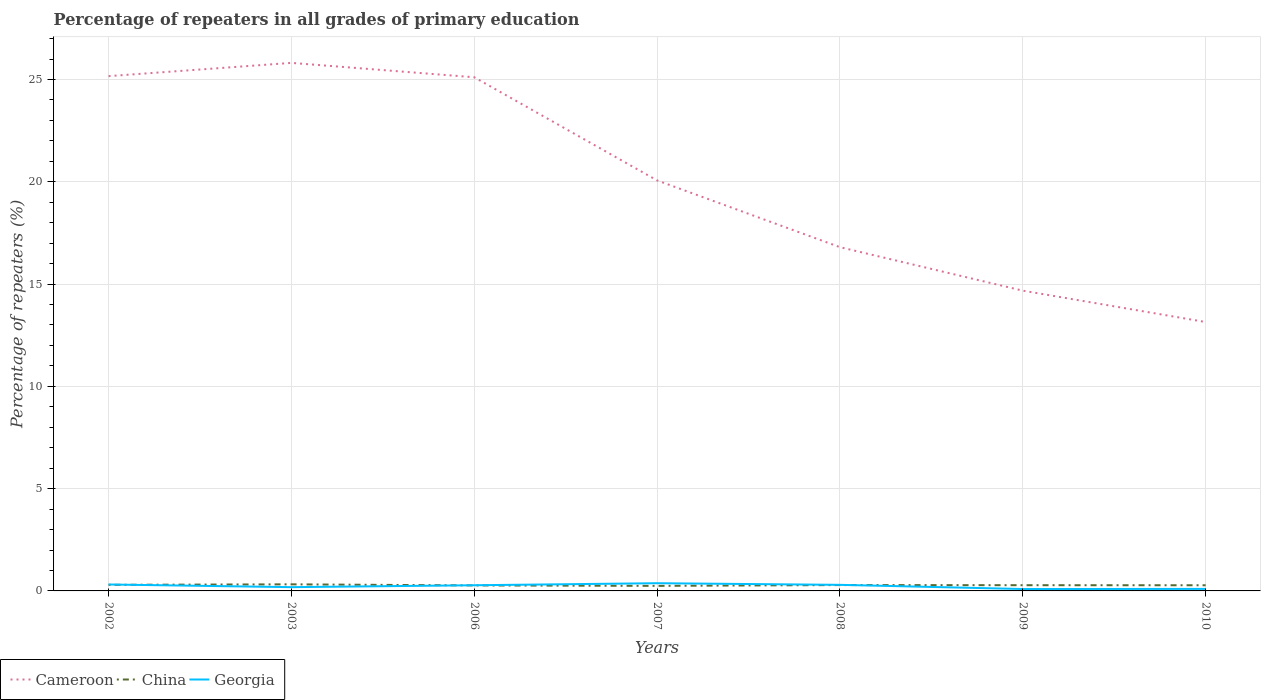How many different coloured lines are there?
Provide a succinct answer. 3. Does the line corresponding to Cameroon intersect with the line corresponding to Georgia?
Keep it short and to the point. No. Across all years, what is the maximum percentage of repeaters in Cameroon?
Give a very brief answer. 13.14. In which year was the percentage of repeaters in China maximum?
Your answer should be very brief. 2007. What is the total percentage of repeaters in Georgia in the graph?
Make the answer very short. 0.22. What is the difference between the highest and the second highest percentage of repeaters in Georgia?
Your answer should be very brief. 0.28. Is the percentage of repeaters in Georgia strictly greater than the percentage of repeaters in China over the years?
Give a very brief answer. No. What is the difference between two consecutive major ticks on the Y-axis?
Give a very brief answer. 5. Are the values on the major ticks of Y-axis written in scientific E-notation?
Provide a succinct answer. No. Where does the legend appear in the graph?
Offer a very short reply. Bottom left. How are the legend labels stacked?
Your answer should be very brief. Horizontal. What is the title of the graph?
Offer a very short reply. Percentage of repeaters in all grades of primary education. Does "Qatar" appear as one of the legend labels in the graph?
Give a very brief answer. No. What is the label or title of the X-axis?
Your response must be concise. Years. What is the label or title of the Y-axis?
Provide a short and direct response. Percentage of repeaters (%). What is the Percentage of repeaters (%) of Cameroon in 2002?
Offer a very short reply. 25.17. What is the Percentage of repeaters (%) of China in 2002?
Offer a very short reply. 0.3. What is the Percentage of repeaters (%) in Georgia in 2002?
Make the answer very short. 0.31. What is the Percentage of repeaters (%) of Cameroon in 2003?
Ensure brevity in your answer.  25.81. What is the Percentage of repeaters (%) of China in 2003?
Your response must be concise. 0.32. What is the Percentage of repeaters (%) of Georgia in 2003?
Ensure brevity in your answer.  0.18. What is the Percentage of repeaters (%) of Cameroon in 2006?
Offer a very short reply. 25.11. What is the Percentage of repeaters (%) of China in 2006?
Keep it short and to the point. 0.27. What is the Percentage of repeaters (%) of Georgia in 2006?
Offer a terse response. 0.28. What is the Percentage of repeaters (%) of Cameroon in 2007?
Give a very brief answer. 20.07. What is the Percentage of repeaters (%) of China in 2007?
Your answer should be compact. 0.25. What is the Percentage of repeaters (%) in Georgia in 2007?
Your response must be concise. 0.38. What is the Percentage of repeaters (%) of Cameroon in 2008?
Provide a succinct answer. 16.8. What is the Percentage of repeaters (%) of China in 2008?
Your response must be concise. 0.29. What is the Percentage of repeaters (%) of Georgia in 2008?
Offer a very short reply. 0.3. What is the Percentage of repeaters (%) of Cameroon in 2009?
Your response must be concise. 14.68. What is the Percentage of repeaters (%) of China in 2009?
Your answer should be very brief. 0.28. What is the Percentage of repeaters (%) in Georgia in 2009?
Make the answer very short. 0.09. What is the Percentage of repeaters (%) in Cameroon in 2010?
Provide a succinct answer. 13.14. What is the Percentage of repeaters (%) of China in 2010?
Your answer should be compact. 0.28. What is the Percentage of repeaters (%) in Georgia in 2010?
Provide a succinct answer. 0.1. Across all years, what is the maximum Percentage of repeaters (%) of Cameroon?
Keep it short and to the point. 25.81. Across all years, what is the maximum Percentage of repeaters (%) in China?
Provide a short and direct response. 0.32. Across all years, what is the maximum Percentage of repeaters (%) of Georgia?
Give a very brief answer. 0.38. Across all years, what is the minimum Percentage of repeaters (%) of Cameroon?
Your answer should be very brief. 13.14. Across all years, what is the minimum Percentage of repeaters (%) of China?
Provide a succinct answer. 0.25. Across all years, what is the minimum Percentage of repeaters (%) in Georgia?
Keep it short and to the point. 0.09. What is the total Percentage of repeaters (%) in Cameroon in the graph?
Ensure brevity in your answer.  140.78. What is the total Percentage of repeaters (%) of China in the graph?
Offer a terse response. 1.98. What is the total Percentage of repeaters (%) in Georgia in the graph?
Provide a succinct answer. 1.64. What is the difference between the Percentage of repeaters (%) of Cameroon in 2002 and that in 2003?
Keep it short and to the point. -0.65. What is the difference between the Percentage of repeaters (%) of China in 2002 and that in 2003?
Offer a very short reply. -0.02. What is the difference between the Percentage of repeaters (%) of Georgia in 2002 and that in 2003?
Offer a very short reply. 0.13. What is the difference between the Percentage of repeaters (%) in Cameroon in 2002 and that in 2006?
Give a very brief answer. 0.06. What is the difference between the Percentage of repeaters (%) in China in 2002 and that in 2006?
Give a very brief answer. 0.03. What is the difference between the Percentage of repeaters (%) in Georgia in 2002 and that in 2006?
Provide a short and direct response. 0.04. What is the difference between the Percentage of repeaters (%) in Cameroon in 2002 and that in 2007?
Provide a short and direct response. 5.1. What is the difference between the Percentage of repeaters (%) of China in 2002 and that in 2007?
Make the answer very short. 0.05. What is the difference between the Percentage of repeaters (%) of Georgia in 2002 and that in 2007?
Your response must be concise. -0.06. What is the difference between the Percentage of repeaters (%) in Cameroon in 2002 and that in 2008?
Your answer should be very brief. 8.36. What is the difference between the Percentage of repeaters (%) of China in 2002 and that in 2008?
Keep it short and to the point. 0.01. What is the difference between the Percentage of repeaters (%) in Georgia in 2002 and that in 2008?
Make the answer very short. 0.02. What is the difference between the Percentage of repeaters (%) in Cameroon in 2002 and that in 2009?
Offer a very short reply. 10.49. What is the difference between the Percentage of repeaters (%) of China in 2002 and that in 2009?
Ensure brevity in your answer.  0.02. What is the difference between the Percentage of repeaters (%) of Georgia in 2002 and that in 2009?
Your answer should be compact. 0.22. What is the difference between the Percentage of repeaters (%) of Cameroon in 2002 and that in 2010?
Your response must be concise. 12.02. What is the difference between the Percentage of repeaters (%) in China in 2002 and that in 2010?
Give a very brief answer. 0.02. What is the difference between the Percentage of repeaters (%) in Georgia in 2002 and that in 2010?
Make the answer very short. 0.22. What is the difference between the Percentage of repeaters (%) in Cameroon in 2003 and that in 2006?
Provide a succinct answer. 0.7. What is the difference between the Percentage of repeaters (%) of China in 2003 and that in 2006?
Keep it short and to the point. 0.05. What is the difference between the Percentage of repeaters (%) of Georgia in 2003 and that in 2006?
Keep it short and to the point. -0.09. What is the difference between the Percentage of repeaters (%) in Cameroon in 2003 and that in 2007?
Provide a short and direct response. 5.75. What is the difference between the Percentage of repeaters (%) of China in 2003 and that in 2007?
Ensure brevity in your answer.  0.08. What is the difference between the Percentage of repeaters (%) of Georgia in 2003 and that in 2007?
Give a very brief answer. -0.19. What is the difference between the Percentage of repeaters (%) of Cameroon in 2003 and that in 2008?
Your answer should be very brief. 9.01. What is the difference between the Percentage of repeaters (%) in China in 2003 and that in 2008?
Your response must be concise. 0.04. What is the difference between the Percentage of repeaters (%) of Georgia in 2003 and that in 2008?
Keep it short and to the point. -0.11. What is the difference between the Percentage of repeaters (%) in Cameroon in 2003 and that in 2009?
Make the answer very short. 11.13. What is the difference between the Percentage of repeaters (%) of China in 2003 and that in 2009?
Ensure brevity in your answer.  0.04. What is the difference between the Percentage of repeaters (%) of Georgia in 2003 and that in 2009?
Provide a short and direct response. 0.09. What is the difference between the Percentage of repeaters (%) in Cameroon in 2003 and that in 2010?
Your answer should be very brief. 12.67. What is the difference between the Percentage of repeaters (%) in China in 2003 and that in 2010?
Offer a very short reply. 0.05. What is the difference between the Percentage of repeaters (%) of Georgia in 2003 and that in 2010?
Ensure brevity in your answer.  0.09. What is the difference between the Percentage of repeaters (%) in Cameroon in 2006 and that in 2007?
Your answer should be very brief. 5.04. What is the difference between the Percentage of repeaters (%) of China in 2006 and that in 2007?
Keep it short and to the point. 0.02. What is the difference between the Percentage of repeaters (%) of Georgia in 2006 and that in 2007?
Keep it short and to the point. -0.1. What is the difference between the Percentage of repeaters (%) of Cameroon in 2006 and that in 2008?
Provide a succinct answer. 8.31. What is the difference between the Percentage of repeaters (%) in China in 2006 and that in 2008?
Provide a short and direct response. -0.02. What is the difference between the Percentage of repeaters (%) of Georgia in 2006 and that in 2008?
Your response must be concise. -0.02. What is the difference between the Percentage of repeaters (%) of Cameroon in 2006 and that in 2009?
Ensure brevity in your answer.  10.43. What is the difference between the Percentage of repeaters (%) of China in 2006 and that in 2009?
Your answer should be compact. -0.01. What is the difference between the Percentage of repeaters (%) of Georgia in 2006 and that in 2009?
Your answer should be compact. 0.18. What is the difference between the Percentage of repeaters (%) of Cameroon in 2006 and that in 2010?
Ensure brevity in your answer.  11.97. What is the difference between the Percentage of repeaters (%) in China in 2006 and that in 2010?
Keep it short and to the point. -0.01. What is the difference between the Percentage of repeaters (%) in Georgia in 2006 and that in 2010?
Your answer should be compact. 0.18. What is the difference between the Percentage of repeaters (%) of Cameroon in 2007 and that in 2008?
Keep it short and to the point. 3.26. What is the difference between the Percentage of repeaters (%) of China in 2007 and that in 2008?
Offer a very short reply. -0.04. What is the difference between the Percentage of repeaters (%) in Georgia in 2007 and that in 2008?
Make the answer very short. 0.08. What is the difference between the Percentage of repeaters (%) in Cameroon in 2007 and that in 2009?
Offer a terse response. 5.39. What is the difference between the Percentage of repeaters (%) of China in 2007 and that in 2009?
Provide a succinct answer. -0.03. What is the difference between the Percentage of repeaters (%) in Georgia in 2007 and that in 2009?
Give a very brief answer. 0.28. What is the difference between the Percentage of repeaters (%) in Cameroon in 2007 and that in 2010?
Give a very brief answer. 6.92. What is the difference between the Percentage of repeaters (%) in China in 2007 and that in 2010?
Make the answer very short. -0.03. What is the difference between the Percentage of repeaters (%) of Georgia in 2007 and that in 2010?
Your answer should be compact. 0.28. What is the difference between the Percentage of repeaters (%) in Cameroon in 2008 and that in 2009?
Offer a terse response. 2.13. What is the difference between the Percentage of repeaters (%) in China in 2008 and that in 2009?
Your answer should be very brief. 0.01. What is the difference between the Percentage of repeaters (%) of Georgia in 2008 and that in 2009?
Keep it short and to the point. 0.2. What is the difference between the Percentage of repeaters (%) of Cameroon in 2008 and that in 2010?
Provide a succinct answer. 3.66. What is the difference between the Percentage of repeaters (%) of China in 2008 and that in 2010?
Ensure brevity in your answer.  0.01. What is the difference between the Percentage of repeaters (%) in Georgia in 2008 and that in 2010?
Offer a very short reply. 0.2. What is the difference between the Percentage of repeaters (%) of Cameroon in 2009 and that in 2010?
Offer a very short reply. 1.53. What is the difference between the Percentage of repeaters (%) in China in 2009 and that in 2010?
Provide a succinct answer. 0. What is the difference between the Percentage of repeaters (%) of Georgia in 2009 and that in 2010?
Keep it short and to the point. -0.01. What is the difference between the Percentage of repeaters (%) in Cameroon in 2002 and the Percentage of repeaters (%) in China in 2003?
Give a very brief answer. 24.84. What is the difference between the Percentage of repeaters (%) in Cameroon in 2002 and the Percentage of repeaters (%) in Georgia in 2003?
Provide a short and direct response. 24.98. What is the difference between the Percentage of repeaters (%) of China in 2002 and the Percentage of repeaters (%) of Georgia in 2003?
Make the answer very short. 0.11. What is the difference between the Percentage of repeaters (%) in Cameroon in 2002 and the Percentage of repeaters (%) in China in 2006?
Offer a very short reply. 24.9. What is the difference between the Percentage of repeaters (%) in Cameroon in 2002 and the Percentage of repeaters (%) in Georgia in 2006?
Offer a very short reply. 24.89. What is the difference between the Percentage of repeaters (%) of China in 2002 and the Percentage of repeaters (%) of Georgia in 2006?
Offer a terse response. 0.02. What is the difference between the Percentage of repeaters (%) of Cameroon in 2002 and the Percentage of repeaters (%) of China in 2007?
Provide a short and direct response. 24.92. What is the difference between the Percentage of repeaters (%) of Cameroon in 2002 and the Percentage of repeaters (%) of Georgia in 2007?
Your response must be concise. 24.79. What is the difference between the Percentage of repeaters (%) of China in 2002 and the Percentage of repeaters (%) of Georgia in 2007?
Ensure brevity in your answer.  -0.08. What is the difference between the Percentage of repeaters (%) in Cameroon in 2002 and the Percentage of repeaters (%) in China in 2008?
Your answer should be compact. 24.88. What is the difference between the Percentage of repeaters (%) in Cameroon in 2002 and the Percentage of repeaters (%) in Georgia in 2008?
Make the answer very short. 24.87. What is the difference between the Percentage of repeaters (%) in Cameroon in 2002 and the Percentage of repeaters (%) in China in 2009?
Your response must be concise. 24.89. What is the difference between the Percentage of repeaters (%) of Cameroon in 2002 and the Percentage of repeaters (%) of Georgia in 2009?
Your answer should be very brief. 25.07. What is the difference between the Percentage of repeaters (%) in China in 2002 and the Percentage of repeaters (%) in Georgia in 2009?
Offer a terse response. 0.21. What is the difference between the Percentage of repeaters (%) in Cameroon in 2002 and the Percentage of repeaters (%) in China in 2010?
Offer a terse response. 24.89. What is the difference between the Percentage of repeaters (%) in Cameroon in 2002 and the Percentage of repeaters (%) in Georgia in 2010?
Make the answer very short. 25.07. What is the difference between the Percentage of repeaters (%) of China in 2002 and the Percentage of repeaters (%) of Georgia in 2010?
Keep it short and to the point. 0.2. What is the difference between the Percentage of repeaters (%) of Cameroon in 2003 and the Percentage of repeaters (%) of China in 2006?
Your response must be concise. 25.54. What is the difference between the Percentage of repeaters (%) of Cameroon in 2003 and the Percentage of repeaters (%) of Georgia in 2006?
Ensure brevity in your answer.  25.54. What is the difference between the Percentage of repeaters (%) in China in 2003 and the Percentage of repeaters (%) in Georgia in 2006?
Your response must be concise. 0.05. What is the difference between the Percentage of repeaters (%) in Cameroon in 2003 and the Percentage of repeaters (%) in China in 2007?
Provide a short and direct response. 25.57. What is the difference between the Percentage of repeaters (%) in Cameroon in 2003 and the Percentage of repeaters (%) in Georgia in 2007?
Provide a succinct answer. 25.44. What is the difference between the Percentage of repeaters (%) in China in 2003 and the Percentage of repeaters (%) in Georgia in 2007?
Provide a short and direct response. -0.06. What is the difference between the Percentage of repeaters (%) of Cameroon in 2003 and the Percentage of repeaters (%) of China in 2008?
Provide a short and direct response. 25.53. What is the difference between the Percentage of repeaters (%) in Cameroon in 2003 and the Percentage of repeaters (%) in Georgia in 2008?
Your answer should be very brief. 25.52. What is the difference between the Percentage of repeaters (%) of China in 2003 and the Percentage of repeaters (%) of Georgia in 2008?
Provide a short and direct response. 0.03. What is the difference between the Percentage of repeaters (%) of Cameroon in 2003 and the Percentage of repeaters (%) of China in 2009?
Ensure brevity in your answer.  25.53. What is the difference between the Percentage of repeaters (%) of Cameroon in 2003 and the Percentage of repeaters (%) of Georgia in 2009?
Give a very brief answer. 25.72. What is the difference between the Percentage of repeaters (%) of China in 2003 and the Percentage of repeaters (%) of Georgia in 2009?
Your response must be concise. 0.23. What is the difference between the Percentage of repeaters (%) of Cameroon in 2003 and the Percentage of repeaters (%) of China in 2010?
Your response must be concise. 25.54. What is the difference between the Percentage of repeaters (%) in Cameroon in 2003 and the Percentage of repeaters (%) in Georgia in 2010?
Keep it short and to the point. 25.71. What is the difference between the Percentage of repeaters (%) in China in 2003 and the Percentage of repeaters (%) in Georgia in 2010?
Provide a succinct answer. 0.22. What is the difference between the Percentage of repeaters (%) in Cameroon in 2006 and the Percentage of repeaters (%) in China in 2007?
Keep it short and to the point. 24.86. What is the difference between the Percentage of repeaters (%) in Cameroon in 2006 and the Percentage of repeaters (%) in Georgia in 2007?
Your response must be concise. 24.73. What is the difference between the Percentage of repeaters (%) of China in 2006 and the Percentage of repeaters (%) of Georgia in 2007?
Offer a terse response. -0.11. What is the difference between the Percentage of repeaters (%) of Cameroon in 2006 and the Percentage of repeaters (%) of China in 2008?
Ensure brevity in your answer.  24.82. What is the difference between the Percentage of repeaters (%) in Cameroon in 2006 and the Percentage of repeaters (%) in Georgia in 2008?
Ensure brevity in your answer.  24.81. What is the difference between the Percentage of repeaters (%) in China in 2006 and the Percentage of repeaters (%) in Georgia in 2008?
Make the answer very short. -0.03. What is the difference between the Percentage of repeaters (%) of Cameroon in 2006 and the Percentage of repeaters (%) of China in 2009?
Offer a very short reply. 24.83. What is the difference between the Percentage of repeaters (%) of Cameroon in 2006 and the Percentage of repeaters (%) of Georgia in 2009?
Your answer should be very brief. 25.02. What is the difference between the Percentage of repeaters (%) in China in 2006 and the Percentage of repeaters (%) in Georgia in 2009?
Your answer should be compact. 0.18. What is the difference between the Percentage of repeaters (%) in Cameroon in 2006 and the Percentage of repeaters (%) in China in 2010?
Give a very brief answer. 24.83. What is the difference between the Percentage of repeaters (%) in Cameroon in 2006 and the Percentage of repeaters (%) in Georgia in 2010?
Provide a short and direct response. 25.01. What is the difference between the Percentage of repeaters (%) of China in 2006 and the Percentage of repeaters (%) of Georgia in 2010?
Your answer should be very brief. 0.17. What is the difference between the Percentage of repeaters (%) of Cameroon in 2007 and the Percentage of repeaters (%) of China in 2008?
Give a very brief answer. 19.78. What is the difference between the Percentage of repeaters (%) in Cameroon in 2007 and the Percentage of repeaters (%) in Georgia in 2008?
Offer a very short reply. 19.77. What is the difference between the Percentage of repeaters (%) of China in 2007 and the Percentage of repeaters (%) of Georgia in 2008?
Provide a succinct answer. -0.05. What is the difference between the Percentage of repeaters (%) of Cameroon in 2007 and the Percentage of repeaters (%) of China in 2009?
Provide a short and direct response. 19.79. What is the difference between the Percentage of repeaters (%) of Cameroon in 2007 and the Percentage of repeaters (%) of Georgia in 2009?
Provide a short and direct response. 19.97. What is the difference between the Percentage of repeaters (%) of China in 2007 and the Percentage of repeaters (%) of Georgia in 2009?
Your answer should be compact. 0.15. What is the difference between the Percentage of repeaters (%) in Cameroon in 2007 and the Percentage of repeaters (%) in China in 2010?
Offer a terse response. 19.79. What is the difference between the Percentage of repeaters (%) in Cameroon in 2007 and the Percentage of repeaters (%) in Georgia in 2010?
Your answer should be very brief. 19.97. What is the difference between the Percentage of repeaters (%) of China in 2007 and the Percentage of repeaters (%) of Georgia in 2010?
Make the answer very short. 0.15. What is the difference between the Percentage of repeaters (%) of Cameroon in 2008 and the Percentage of repeaters (%) of China in 2009?
Provide a short and direct response. 16.52. What is the difference between the Percentage of repeaters (%) of Cameroon in 2008 and the Percentage of repeaters (%) of Georgia in 2009?
Your response must be concise. 16.71. What is the difference between the Percentage of repeaters (%) in China in 2008 and the Percentage of repeaters (%) in Georgia in 2009?
Your answer should be compact. 0.19. What is the difference between the Percentage of repeaters (%) in Cameroon in 2008 and the Percentage of repeaters (%) in China in 2010?
Keep it short and to the point. 16.53. What is the difference between the Percentage of repeaters (%) of Cameroon in 2008 and the Percentage of repeaters (%) of Georgia in 2010?
Provide a short and direct response. 16.71. What is the difference between the Percentage of repeaters (%) in China in 2008 and the Percentage of repeaters (%) in Georgia in 2010?
Offer a very short reply. 0.19. What is the difference between the Percentage of repeaters (%) in Cameroon in 2009 and the Percentage of repeaters (%) in China in 2010?
Your answer should be very brief. 14.4. What is the difference between the Percentage of repeaters (%) in Cameroon in 2009 and the Percentage of repeaters (%) in Georgia in 2010?
Your answer should be very brief. 14.58. What is the difference between the Percentage of repeaters (%) in China in 2009 and the Percentage of repeaters (%) in Georgia in 2010?
Make the answer very short. 0.18. What is the average Percentage of repeaters (%) in Cameroon per year?
Your response must be concise. 20.11. What is the average Percentage of repeaters (%) in China per year?
Make the answer very short. 0.28. What is the average Percentage of repeaters (%) of Georgia per year?
Offer a very short reply. 0.23. In the year 2002, what is the difference between the Percentage of repeaters (%) of Cameroon and Percentage of repeaters (%) of China?
Provide a succinct answer. 24.87. In the year 2002, what is the difference between the Percentage of repeaters (%) in Cameroon and Percentage of repeaters (%) in Georgia?
Your response must be concise. 24.85. In the year 2002, what is the difference between the Percentage of repeaters (%) of China and Percentage of repeaters (%) of Georgia?
Offer a very short reply. -0.02. In the year 2003, what is the difference between the Percentage of repeaters (%) of Cameroon and Percentage of repeaters (%) of China?
Your answer should be very brief. 25.49. In the year 2003, what is the difference between the Percentage of repeaters (%) in Cameroon and Percentage of repeaters (%) in Georgia?
Offer a terse response. 25.63. In the year 2003, what is the difference between the Percentage of repeaters (%) in China and Percentage of repeaters (%) in Georgia?
Provide a succinct answer. 0.14. In the year 2006, what is the difference between the Percentage of repeaters (%) of Cameroon and Percentage of repeaters (%) of China?
Ensure brevity in your answer.  24.84. In the year 2006, what is the difference between the Percentage of repeaters (%) in Cameroon and Percentage of repeaters (%) in Georgia?
Provide a short and direct response. 24.83. In the year 2006, what is the difference between the Percentage of repeaters (%) of China and Percentage of repeaters (%) of Georgia?
Offer a terse response. -0.01. In the year 2007, what is the difference between the Percentage of repeaters (%) in Cameroon and Percentage of repeaters (%) in China?
Your answer should be compact. 19.82. In the year 2007, what is the difference between the Percentage of repeaters (%) in Cameroon and Percentage of repeaters (%) in Georgia?
Give a very brief answer. 19.69. In the year 2007, what is the difference between the Percentage of repeaters (%) of China and Percentage of repeaters (%) of Georgia?
Ensure brevity in your answer.  -0.13. In the year 2008, what is the difference between the Percentage of repeaters (%) in Cameroon and Percentage of repeaters (%) in China?
Make the answer very short. 16.52. In the year 2008, what is the difference between the Percentage of repeaters (%) in Cameroon and Percentage of repeaters (%) in Georgia?
Give a very brief answer. 16.51. In the year 2008, what is the difference between the Percentage of repeaters (%) of China and Percentage of repeaters (%) of Georgia?
Your answer should be very brief. -0.01. In the year 2009, what is the difference between the Percentage of repeaters (%) in Cameroon and Percentage of repeaters (%) in China?
Your answer should be very brief. 14.4. In the year 2009, what is the difference between the Percentage of repeaters (%) in Cameroon and Percentage of repeaters (%) in Georgia?
Provide a short and direct response. 14.59. In the year 2009, what is the difference between the Percentage of repeaters (%) in China and Percentage of repeaters (%) in Georgia?
Make the answer very short. 0.19. In the year 2010, what is the difference between the Percentage of repeaters (%) in Cameroon and Percentage of repeaters (%) in China?
Offer a terse response. 12.87. In the year 2010, what is the difference between the Percentage of repeaters (%) in Cameroon and Percentage of repeaters (%) in Georgia?
Keep it short and to the point. 13.05. In the year 2010, what is the difference between the Percentage of repeaters (%) of China and Percentage of repeaters (%) of Georgia?
Your response must be concise. 0.18. What is the ratio of the Percentage of repeaters (%) of Cameroon in 2002 to that in 2003?
Make the answer very short. 0.97. What is the ratio of the Percentage of repeaters (%) in China in 2002 to that in 2003?
Ensure brevity in your answer.  0.92. What is the ratio of the Percentage of repeaters (%) of Georgia in 2002 to that in 2003?
Make the answer very short. 1.71. What is the ratio of the Percentage of repeaters (%) of Cameroon in 2002 to that in 2006?
Offer a terse response. 1. What is the ratio of the Percentage of repeaters (%) of China in 2002 to that in 2006?
Your response must be concise. 1.11. What is the ratio of the Percentage of repeaters (%) in Georgia in 2002 to that in 2006?
Make the answer very short. 1.13. What is the ratio of the Percentage of repeaters (%) of Cameroon in 2002 to that in 2007?
Keep it short and to the point. 1.25. What is the ratio of the Percentage of repeaters (%) of China in 2002 to that in 2007?
Offer a terse response. 1.21. What is the ratio of the Percentage of repeaters (%) in Georgia in 2002 to that in 2007?
Keep it short and to the point. 0.83. What is the ratio of the Percentage of repeaters (%) of Cameroon in 2002 to that in 2008?
Keep it short and to the point. 1.5. What is the ratio of the Percentage of repeaters (%) in China in 2002 to that in 2008?
Provide a succinct answer. 1.04. What is the ratio of the Percentage of repeaters (%) in Georgia in 2002 to that in 2008?
Provide a short and direct response. 1.06. What is the ratio of the Percentage of repeaters (%) in Cameroon in 2002 to that in 2009?
Offer a terse response. 1.71. What is the ratio of the Percentage of repeaters (%) of China in 2002 to that in 2009?
Offer a terse response. 1.06. What is the ratio of the Percentage of repeaters (%) in Georgia in 2002 to that in 2009?
Provide a short and direct response. 3.39. What is the ratio of the Percentage of repeaters (%) of Cameroon in 2002 to that in 2010?
Your response must be concise. 1.91. What is the ratio of the Percentage of repeaters (%) of China in 2002 to that in 2010?
Offer a very short reply. 1.08. What is the ratio of the Percentage of repeaters (%) in Georgia in 2002 to that in 2010?
Provide a succinct answer. 3.2. What is the ratio of the Percentage of repeaters (%) of Cameroon in 2003 to that in 2006?
Ensure brevity in your answer.  1.03. What is the ratio of the Percentage of repeaters (%) of China in 2003 to that in 2006?
Your answer should be very brief. 1.2. What is the ratio of the Percentage of repeaters (%) in Georgia in 2003 to that in 2006?
Provide a succinct answer. 0.67. What is the ratio of the Percentage of repeaters (%) in Cameroon in 2003 to that in 2007?
Provide a succinct answer. 1.29. What is the ratio of the Percentage of repeaters (%) in China in 2003 to that in 2007?
Ensure brevity in your answer.  1.31. What is the ratio of the Percentage of repeaters (%) in Georgia in 2003 to that in 2007?
Your answer should be very brief. 0.49. What is the ratio of the Percentage of repeaters (%) in Cameroon in 2003 to that in 2008?
Your answer should be compact. 1.54. What is the ratio of the Percentage of repeaters (%) of China in 2003 to that in 2008?
Your answer should be compact. 1.12. What is the ratio of the Percentage of repeaters (%) of Georgia in 2003 to that in 2008?
Your response must be concise. 0.62. What is the ratio of the Percentage of repeaters (%) of Cameroon in 2003 to that in 2009?
Provide a succinct answer. 1.76. What is the ratio of the Percentage of repeaters (%) in China in 2003 to that in 2009?
Offer a very short reply. 1.15. What is the ratio of the Percentage of repeaters (%) of Georgia in 2003 to that in 2009?
Your response must be concise. 1.99. What is the ratio of the Percentage of repeaters (%) in Cameroon in 2003 to that in 2010?
Your answer should be very brief. 1.96. What is the ratio of the Percentage of repeaters (%) in China in 2003 to that in 2010?
Give a very brief answer. 1.16. What is the ratio of the Percentage of repeaters (%) of Georgia in 2003 to that in 2010?
Your answer should be compact. 1.88. What is the ratio of the Percentage of repeaters (%) in Cameroon in 2006 to that in 2007?
Your response must be concise. 1.25. What is the ratio of the Percentage of repeaters (%) in China in 2006 to that in 2007?
Your response must be concise. 1.09. What is the ratio of the Percentage of repeaters (%) in Georgia in 2006 to that in 2007?
Keep it short and to the point. 0.73. What is the ratio of the Percentage of repeaters (%) in Cameroon in 2006 to that in 2008?
Provide a succinct answer. 1.49. What is the ratio of the Percentage of repeaters (%) of China in 2006 to that in 2008?
Your response must be concise. 0.94. What is the ratio of the Percentage of repeaters (%) of Georgia in 2006 to that in 2008?
Your answer should be very brief. 0.93. What is the ratio of the Percentage of repeaters (%) of Cameroon in 2006 to that in 2009?
Keep it short and to the point. 1.71. What is the ratio of the Percentage of repeaters (%) of China in 2006 to that in 2009?
Give a very brief answer. 0.96. What is the ratio of the Percentage of repeaters (%) in Georgia in 2006 to that in 2009?
Keep it short and to the point. 2.99. What is the ratio of the Percentage of repeaters (%) in Cameroon in 2006 to that in 2010?
Provide a short and direct response. 1.91. What is the ratio of the Percentage of repeaters (%) in China in 2006 to that in 2010?
Offer a very short reply. 0.97. What is the ratio of the Percentage of repeaters (%) of Georgia in 2006 to that in 2010?
Offer a terse response. 2.82. What is the ratio of the Percentage of repeaters (%) of Cameroon in 2007 to that in 2008?
Offer a very short reply. 1.19. What is the ratio of the Percentage of repeaters (%) of China in 2007 to that in 2008?
Your response must be concise. 0.86. What is the ratio of the Percentage of repeaters (%) in Georgia in 2007 to that in 2008?
Offer a terse response. 1.27. What is the ratio of the Percentage of repeaters (%) in Cameroon in 2007 to that in 2009?
Your answer should be very brief. 1.37. What is the ratio of the Percentage of repeaters (%) in China in 2007 to that in 2009?
Ensure brevity in your answer.  0.88. What is the ratio of the Percentage of repeaters (%) in Georgia in 2007 to that in 2009?
Your answer should be compact. 4.07. What is the ratio of the Percentage of repeaters (%) in Cameroon in 2007 to that in 2010?
Offer a very short reply. 1.53. What is the ratio of the Percentage of repeaters (%) of China in 2007 to that in 2010?
Offer a terse response. 0.89. What is the ratio of the Percentage of repeaters (%) in Georgia in 2007 to that in 2010?
Provide a short and direct response. 3.84. What is the ratio of the Percentage of repeaters (%) in Cameroon in 2008 to that in 2009?
Offer a very short reply. 1.14. What is the ratio of the Percentage of repeaters (%) of China in 2008 to that in 2009?
Ensure brevity in your answer.  1.02. What is the ratio of the Percentage of repeaters (%) of Georgia in 2008 to that in 2009?
Your answer should be compact. 3.2. What is the ratio of the Percentage of repeaters (%) in Cameroon in 2008 to that in 2010?
Provide a short and direct response. 1.28. What is the ratio of the Percentage of repeaters (%) of China in 2008 to that in 2010?
Keep it short and to the point. 1.04. What is the ratio of the Percentage of repeaters (%) of Georgia in 2008 to that in 2010?
Offer a very short reply. 3.02. What is the ratio of the Percentage of repeaters (%) in Cameroon in 2009 to that in 2010?
Offer a very short reply. 1.12. What is the ratio of the Percentage of repeaters (%) of China in 2009 to that in 2010?
Provide a short and direct response. 1.01. What is the ratio of the Percentage of repeaters (%) in Georgia in 2009 to that in 2010?
Give a very brief answer. 0.94. What is the difference between the highest and the second highest Percentage of repeaters (%) of Cameroon?
Provide a short and direct response. 0.65. What is the difference between the highest and the second highest Percentage of repeaters (%) of China?
Make the answer very short. 0.02. What is the difference between the highest and the second highest Percentage of repeaters (%) of Georgia?
Make the answer very short. 0.06. What is the difference between the highest and the lowest Percentage of repeaters (%) in Cameroon?
Your answer should be compact. 12.67. What is the difference between the highest and the lowest Percentage of repeaters (%) in China?
Keep it short and to the point. 0.08. What is the difference between the highest and the lowest Percentage of repeaters (%) in Georgia?
Offer a terse response. 0.28. 